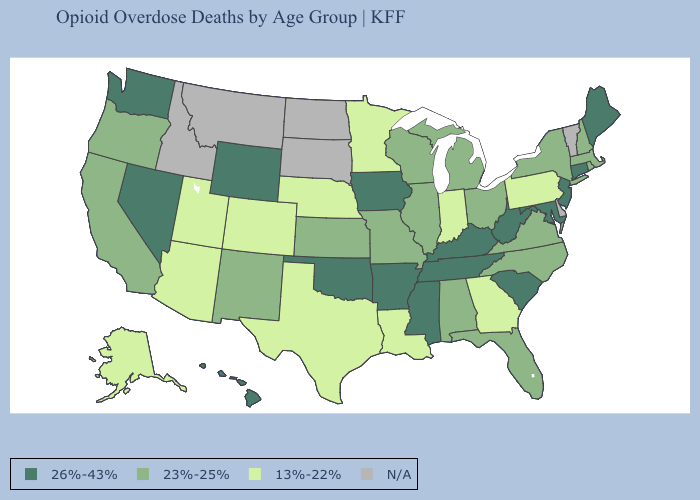What is the highest value in the USA?
Concise answer only. 26%-43%. Is the legend a continuous bar?
Quick response, please. No. Name the states that have a value in the range 26%-43%?
Short answer required. Arkansas, Connecticut, Hawaii, Iowa, Kentucky, Maine, Maryland, Mississippi, Nevada, New Jersey, Oklahoma, South Carolina, Tennessee, Washington, West Virginia, Wyoming. Which states have the highest value in the USA?
Concise answer only. Arkansas, Connecticut, Hawaii, Iowa, Kentucky, Maine, Maryland, Mississippi, Nevada, New Jersey, Oklahoma, South Carolina, Tennessee, Washington, West Virginia, Wyoming. What is the highest value in the USA?
Short answer required. 26%-43%. Name the states that have a value in the range N/A?
Keep it brief. Delaware, Idaho, Montana, North Dakota, South Dakota, Vermont. How many symbols are there in the legend?
Short answer required. 4. Name the states that have a value in the range 26%-43%?
Short answer required. Arkansas, Connecticut, Hawaii, Iowa, Kentucky, Maine, Maryland, Mississippi, Nevada, New Jersey, Oklahoma, South Carolina, Tennessee, Washington, West Virginia, Wyoming. Does South Carolina have the highest value in the USA?
Keep it brief. Yes. What is the highest value in states that border South Carolina?
Answer briefly. 23%-25%. Name the states that have a value in the range N/A?
Quick response, please. Delaware, Idaho, Montana, North Dakota, South Dakota, Vermont. Which states have the lowest value in the West?
Be succinct. Alaska, Arizona, Colorado, Utah. Name the states that have a value in the range N/A?
Short answer required. Delaware, Idaho, Montana, North Dakota, South Dakota, Vermont. What is the value of Arizona?
Write a very short answer. 13%-22%. 